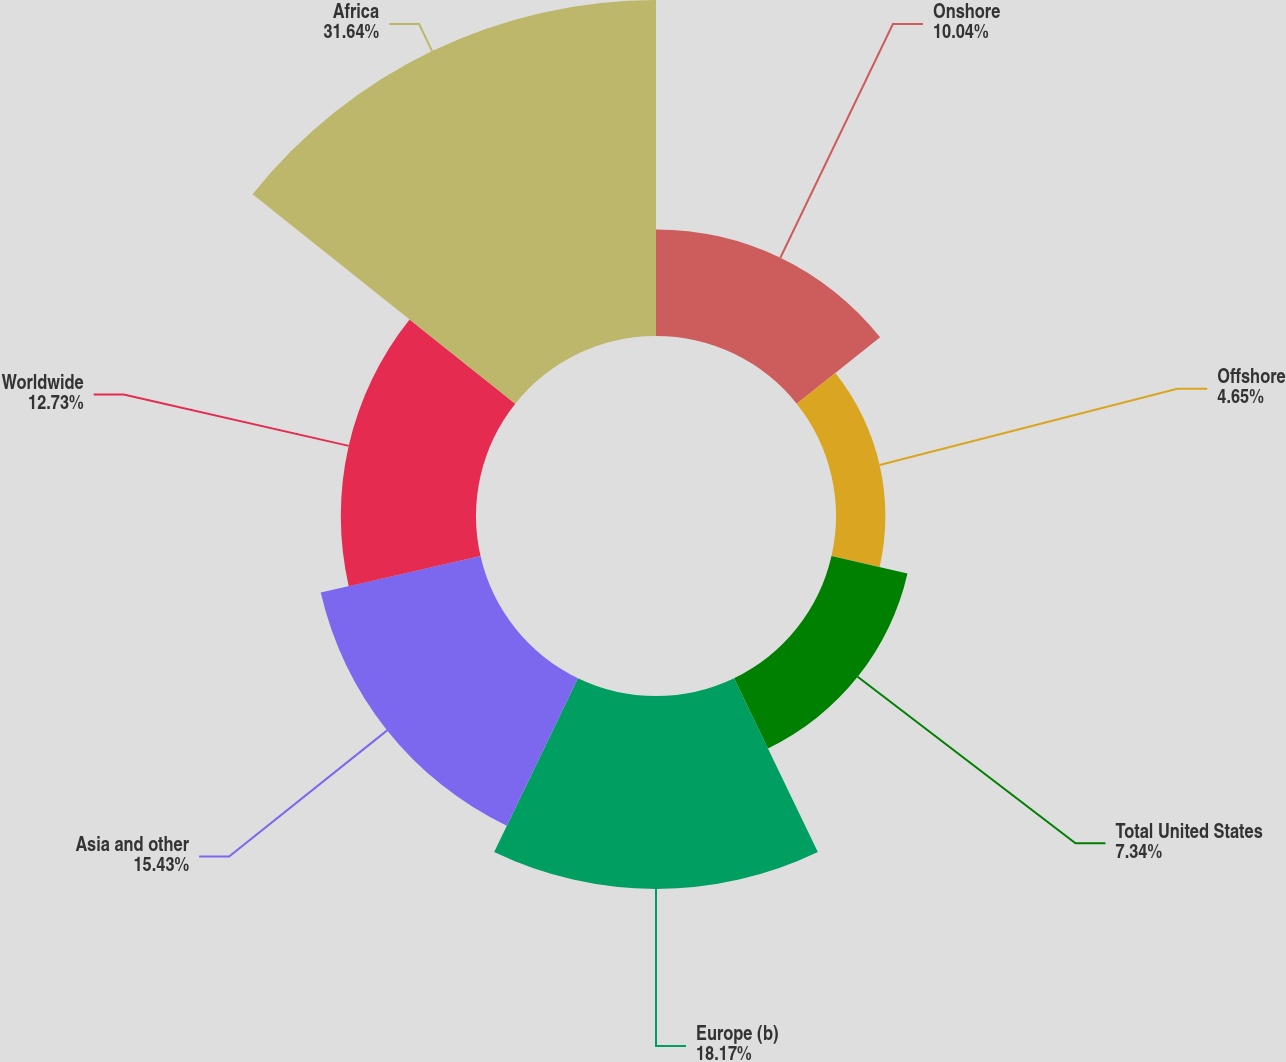<chart> <loc_0><loc_0><loc_500><loc_500><pie_chart><fcel>Onshore<fcel>Offshore<fcel>Total United States<fcel>Europe (b)<fcel>Asia and other<fcel>Worldwide<fcel>Africa<nl><fcel>10.04%<fcel>4.65%<fcel>7.34%<fcel>18.17%<fcel>15.43%<fcel>12.73%<fcel>31.64%<nl></chart> 